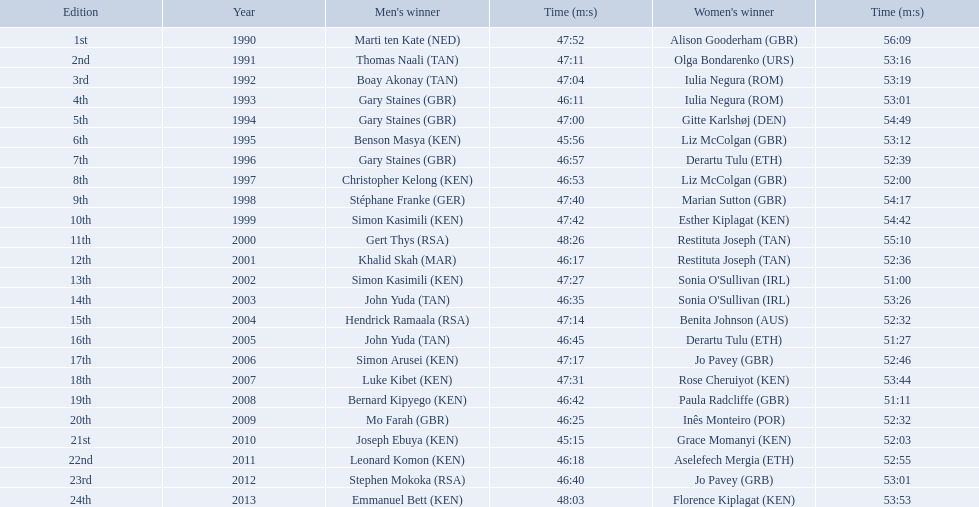Which runners are from kenya? (ken) Benson Masya (KEN), Christopher Kelong (KEN), Simon Kasimili (KEN), Simon Kasimili (KEN), Simon Arusei (KEN), Luke Kibet (KEN), Bernard Kipyego (KEN), Joseph Ebuya (KEN), Leonard Komon (KEN), Emmanuel Bett (KEN). Of these, which times are under 46 minutes? Benson Masya (KEN), Joseph Ebuya (KEN). Which of these runners had the faster time? Joseph Ebuya (KEN). Who were all the runners' times between 1990 and 2013? 47:52, 56:09, 47:11, 53:16, 47:04, 53:19, 46:11, 53:01, 47:00, 54:49, 45:56, 53:12, 46:57, 52:39, 46:53, 52:00, 47:40, 54:17, 47:42, 54:42, 48:26, 55:10, 46:17, 52:36, 47:27, 51:00, 46:35, 53:26, 47:14, 52:32, 46:45, 51:27, 47:17, 52:46, 47:31, 53:44, 46:42, 51:11, 46:25, 52:32, 45:15, 52:03, 46:18, 52:55, 46:40, 53:01, 48:03, 53:53. Which was the fastest time? 45:15. Who ran that time? Joseph Ebuya (KEN). What are the names of each male winner? Marti ten Kate (NED), Thomas Naali (TAN), Boay Akonay (TAN), Gary Staines (GBR), Gary Staines (GBR), Benson Masya (KEN), Gary Staines (GBR), Christopher Kelong (KEN), Stéphane Franke (GER), Simon Kasimili (KEN), Gert Thys (RSA), Khalid Skah (MAR), Simon Kasimili (KEN), John Yuda (TAN), Hendrick Ramaala (RSA), John Yuda (TAN), Simon Arusei (KEN), Luke Kibet (KEN), Bernard Kipyego (KEN), Mo Farah (GBR), Joseph Ebuya (KEN), Leonard Komon (KEN), Stephen Mokoka (RSA), Emmanuel Bett (KEN). When did they race? 1990, 1991, 1992, 1993, 1994, 1995, 1996, 1997, 1998, 1999, 2000, 2001, 2002, 2003, 2004, 2005, 2006, 2007, 2008, 2009, 2010, 2011, 2012, 2013. Can you parse all the data within this table? {'header': ['Edition', 'Year', "Men's winner", 'Time (m:s)', "Women's winner", 'Time (m:s)'], 'rows': [['1st', '1990', 'Marti ten Kate\xa0(NED)', '47:52', 'Alison Gooderham\xa0(GBR)', '56:09'], ['2nd', '1991', 'Thomas Naali\xa0(TAN)', '47:11', 'Olga Bondarenko\xa0(URS)', '53:16'], ['3rd', '1992', 'Boay Akonay\xa0(TAN)', '47:04', 'Iulia Negura\xa0(ROM)', '53:19'], ['4th', '1993', 'Gary Staines\xa0(GBR)', '46:11', 'Iulia Negura\xa0(ROM)', '53:01'], ['5th', '1994', 'Gary Staines\xa0(GBR)', '47:00', 'Gitte Karlshøj\xa0(DEN)', '54:49'], ['6th', '1995', 'Benson Masya\xa0(KEN)', '45:56', 'Liz McColgan\xa0(GBR)', '53:12'], ['7th', '1996', 'Gary Staines\xa0(GBR)', '46:57', 'Derartu Tulu\xa0(ETH)', '52:39'], ['8th', '1997', 'Christopher Kelong\xa0(KEN)', '46:53', 'Liz McColgan\xa0(GBR)', '52:00'], ['9th', '1998', 'Stéphane Franke\xa0(GER)', '47:40', 'Marian Sutton\xa0(GBR)', '54:17'], ['10th', '1999', 'Simon Kasimili\xa0(KEN)', '47:42', 'Esther Kiplagat\xa0(KEN)', '54:42'], ['11th', '2000', 'Gert Thys\xa0(RSA)', '48:26', 'Restituta Joseph\xa0(TAN)', '55:10'], ['12th', '2001', 'Khalid Skah\xa0(MAR)', '46:17', 'Restituta Joseph\xa0(TAN)', '52:36'], ['13th', '2002', 'Simon Kasimili\xa0(KEN)', '47:27', "Sonia O'Sullivan\xa0(IRL)", '51:00'], ['14th', '2003', 'John Yuda\xa0(TAN)', '46:35', "Sonia O'Sullivan\xa0(IRL)", '53:26'], ['15th', '2004', 'Hendrick Ramaala\xa0(RSA)', '47:14', 'Benita Johnson\xa0(AUS)', '52:32'], ['16th', '2005', 'John Yuda\xa0(TAN)', '46:45', 'Derartu Tulu\xa0(ETH)', '51:27'], ['17th', '2006', 'Simon Arusei\xa0(KEN)', '47:17', 'Jo Pavey\xa0(GBR)', '52:46'], ['18th', '2007', 'Luke Kibet\xa0(KEN)', '47:31', 'Rose Cheruiyot\xa0(KEN)', '53:44'], ['19th', '2008', 'Bernard Kipyego\xa0(KEN)', '46:42', 'Paula Radcliffe\xa0(GBR)', '51:11'], ['20th', '2009', 'Mo Farah\xa0(GBR)', '46:25', 'Inês Monteiro\xa0(POR)', '52:32'], ['21st', '2010', 'Joseph Ebuya\xa0(KEN)', '45:15', 'Grace Momanyi\xa0(KEN)', '52:03'], ['22nd', '2011', 'Leonard Komon\xa0(KEN)', '46:18', 'Aselefech Mergia\xa0(ETH)', '52:55'], ['23rd', '2012', 'Stephen Mokoka\xa0(RSA)', '46:40', 'Jo Pavey\xa0(GRB)', '53:01'], ['24th', '2013', 'Emmanuel Bett\xa0(KEN)', '48:03', 'Florence Kiplagat\xa0(KEN)', '53:53']]} And what were their times? 47:52, 47:11, 47:04, 46:11, 47:00, 45:56, 46:57, 46:53, 47:40, 47:42, 48:26, 46:17, 47:27, 46:35, 47:14, 46:45, 47:17, 47:31, 46:42, 46:25, 45:15, 46:18, 46:40, 48:03. Of those times, which athlete had the fastest time? Joseph Ebuya (KEN). Which athletes are from kenya? Benson Masya (KEN), Christopher Kelong (KEN), Simon Kasimili (KEN), Simon Kasimili (KEN), Simon Arusei (KEN), Luke Kibet (KEN), Bernard Kipyego (KEN), Joseph Ebuya (KEN), Leonard Komon (KEN), Emmanuel Bett (KEN). (ken) among them, who has a time below 46 minutes? Benson Masya (KEN), Joseph Ebuya (KEN). Which of these athletes recorded the quickest time? Joseph Ebuya (KEN). What are the monikers of all male champions? Marti ten Kate (NED), Thomas Naali (TAN), Boay Akonay (TAN), Gary Staines (GBR), Gary Staines (GBR), Benson Masya (KEN), Gary Staines (GBR), Christopher Kelong (KEN), Stéphane Franke (GER), Simon Kasimili (KEN), Gert Thys (RSA), Khalid Skah (MAR), Simon Kasimili (KEN), John Yuda (TAN), Hendrick Ramaala (RSA), John Yuda (TAN), Simon Arusei (KEN), Luke Kibet (KEN), Bernard Kipyego (KEN), Mo Farah (GBR), Joseph Ebuya (KEN), Leonard Komon (KEN), Stephen Mokoka (RSA), Emmanuel Bett (KEN). When did they participate? 1990, 1991, 1992, 1993, 1994, 1995, 1996, 1997, 1998, 1999, 2000, 2001, 2002, 2003, 2004, 2005, 2006, 2007, 2008, 2009, 2010, 2011, 2012, 2013. And what were their records? 47:52, 47:11, 47:04, 46:11, 47:00, 45:56, 46:57, 46:53, 47:40, 47:42, 48:26, 46:17, 47:27, 46:35, 47:14, 46:45, 47:17, 47:31, 46:42, 46:25, 45:15, 46:18, 46:40, 48:03. Of those records, which competitor had the swiftest time? Joseph Ebuya (KEN). Which racers are kenyan? Benson Masya (KEN), Christopher Kelong (KEN), Simon Kasimili (KEN), Simon Kasimili (KEN), Simon Arusei (KEN), Luke Kibet (KEN), Bernard Kipyego (KEN), Joseph Ebuya (KEN), Leonard Komon (KEN), Emmanuel Bett (KEN). (ken) from these, who completed in under 46 minutes? Benson Masya (KEN), Joseph Ebuya (KEN). Which of these racers had the swiftest time? Joseph Ebuya (KEN). During which years were the contests conducted? 1990, 1991, 1992, 1993, 1994, 1995, 1996, 1997, 1998, 1999, 2000, 2001, 2002, 2003, 2004, 2005, 2006, 2007, 2008, 2009, 2010, 2011, 2012, 2013. Who was the 2003 female victor? Sonia O'Sullivan (IRL). What was her record time? 53:26. Which of the participants in the great south run were female? Alison Gooderham (GBR), Olga Bondarenko (URS), Iulia Negura (ROM), Iulia Negura (ROM), Gitte Karlshøj (DEN), Liz McColgan (GBR), Derartu Tulu (ETH), Liz McColgan (GBR), Marian Sutton (GBR), Esther Kiplagat (KEN), Restituta Joseph (TAN), Restituta Joseph (TAN), Sonia O'Sullivan (IRL), Sonia O'Sullivan (IRL), Benita Johnson (AUS), Derartu Tulu (ETH), Jo Pavey (GBR), Rose Cheruiyot (KEN), Paula Radcliffe (GBR), Inês Monteiro (POR), Grace Momanyi (KEN), Aselefech Mergia (ETH), Jo Pavey (GRB), Florence Kiplagat (KEN). Among those females, which ones achieved a time of at least 53 minutes? Alison Gooderham (GBR), Olga Bondarenko (URS), Iulia Negura (ROM), Iulia Negura (ROM), Gitte Karlshøj (DEN), Liz McColgan (GBR), Marian Sutton (GBR), Esther Kiplagat (KEN), Restituta Joseph (TAN), Sonia O'Sullivan (IRL), Rose Cheruiyot (KEN), Jo Pavey (GRB), Florence Kiplagat (KEN). Among those females, which ones did not exceed 53 minutes? Olga Bondarenko (URS), Iulia Negura (ROM), Iulia Negura (ROM), Liz McColgan (GBR), Sonia O'Sullivan (IRL), Rose Cheruiyot (KEN), Jo Pavey (GRB), Florence Kiplagat (KEN). Out of those 8, what were the three slowest times? Sonia O'Sullivan (IRL), Rose Cheruiyot (KEN), Florence Kiplagat (KEN). Among only those 3 females, which athlete had the quickest time? Sonia O'Sullivan (IRL). What was this woman's time? 53:26. What are the designations of each male conqueror? Marti ten Kate (NED), Thomas Naali (TAN), Boay Akonay (TAN), Gary Staines (GBR), Gary Staines (GBR), Benson Masya (KEN), Gary Staines (GBR), Christopher Kelong (KEN), Stéphane Franke (GER), Simon Kasimili (KEN), Gert Thys (RSA), Khalid Skah (MAR), Simon Kasimili (KEN), John Yuda (TAN), Hendrick Ramaala (RSA), John Yuda (TAN), Simon Arusei (KEN), Luke Kibet (KEN), Bernard Kipyego (KEN), Mo Farah (GBR), Joseph Ebuya (KEN), Leonard Komon (KEN), Stephen Mokoka (RSA), Emmanuel Bett (KEN). When did they run? 1990, 1991, 1992, 1993, 1994, 1995, 1996, 1997, 1998, 1999, 2000, 2001, 2002, 2003, 2004, 2005, 2006, 2007, 2008, 2009, 2010, 2011, 2012, 2013. And what were their timings? 47:52, 47:11, 47:04, 46:11, 47:00, 45:56, 46:57, 46:53, 47:40, 47:42, 48:26, 46:17, 47:27, 46:35, 47:14, 46:45, 47:17, 47:31, 46:42, 46:25, 45:15, 46:18, 46:40, 48:03. From those timings, which athlete achieved the speediest time? Joseph Ebuya (KEN). 